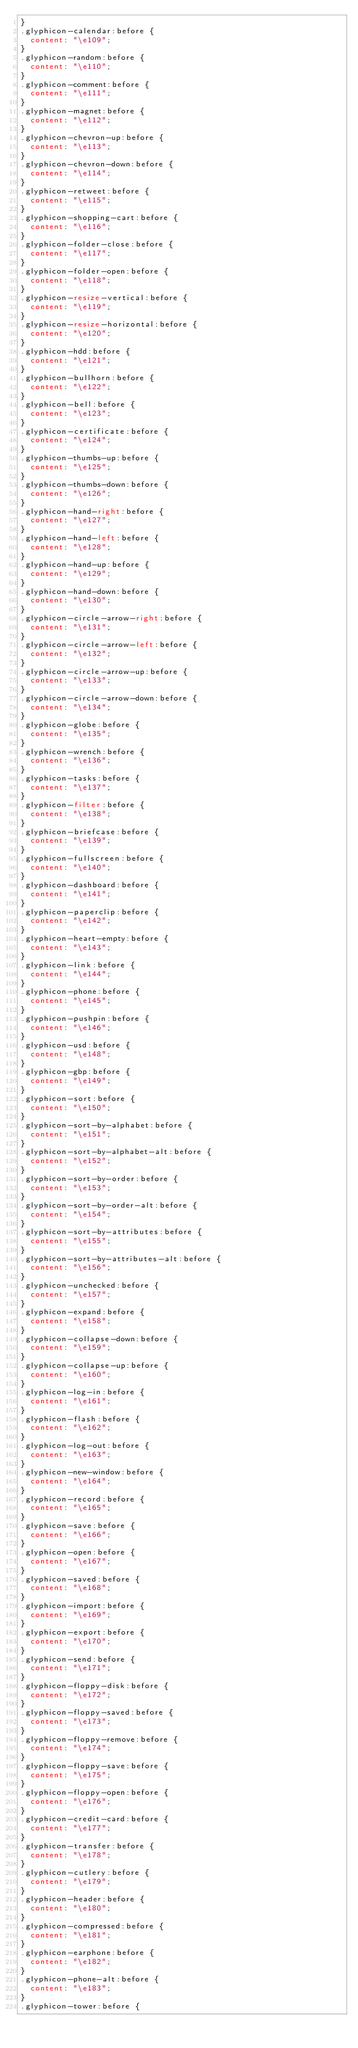<code> <loc_0><loc_0><loc_500><loc_500><_CSS_>}
.glyphicon-calendar:before {
  content: "\e109";
}
.glyphicon-random:before {
  content: "\e110";
}
.glyphicon-comment:before {
  content: "\e111";
}
.glyphicon-magnet:before {
  content: "\e112";
}
.glyphicon-chevron-up:before {
  content: "\e113";
}
.glyphicon-chevron-down:before {
  content: "\e114";
}
.glyphicon-retweet:before {
  content: "\e115";
}
.glyphicon-shopping-cart:before {
  content: "\e116";
}
.glyphicon-folder-close:before {
  content: "\e117";
}
.glyphicon-folder-open:before {
  content: "\e118";
}
.glyphicon-resize-vertical:before {
  content: "\e119";
}
.glyphicon-resize-horizontal:before {
  content: "\e120";
}
.glyphicon-hdd:before {
  content: "\e121";
}
.glyphicon-bullhorn:before {
  content: "\e122";
}
.glyphicon-bell:before {
  content: "\e123";
}
.glyphicon-certificate:before {
  content: "\e124";
}
.glyphicon-thumbs-up:before {
  content: "\e125";
}
.glyphicon-thumbs-down:before {
  content: "\e126";
}
.glyphicon-hand-right:before {
  content: "\e127";
}
.glyphicon-hand-left:before {
  content: "\e128";
}
.glyphicon-hand-up:before {
  content: "\e129";
}
.glyphicon-hand-down:before {
  content: "\e130";
}
.glyphicon-circle-arrow-right:before {
  content: "\e131";
}
.glyphicon-circle-arrow-left:before {
  content: "\e132";
}
.glyphicon-circle-arrow-up:before {
  content: "\e133";
}
.glyphicon-circle-arrow-down:before {
  content: "\e134";
}
.glyphicon-globe:before {
  content: "\e135";
}
.glyphicon-wrench:before {
  content: "\e136";
}
.glyphicon-tasks:before {
  content: "\e137";
}
.glyphicon-filter:before {
  content: "\e138";
}
.glyphicon-briefcase:before {
  content: "\e139";
}
.glyphicon-fullscreen:before {
  content: "\e140";
}
.glyphicon-dashboard:before {
  content: "\e141";
}
.glyphicon-paperclip:before {
  content: "\e142";
}
.glyphicon-heart-empty:before {
  content: "\e143";
}
.glyphicon-link:before {
  content: "\e144";
}
.glyphicon-phone:before {
  content: "\e145";
}
.glyphicon-pushpin:before {
  content: "\e146";
}
.glyphicon-usd:before {
  content: "\e148";
}
.glyphicon-gbp:before {
  content: "\e149";
}
.glyphicon-sort:before {
  content: "\e150";
}
.glyphicon-sort-by-alphabet:before {
  content: "\e151";
}
.glyphicon-sort-by-alphabet-alt:before {
  content: "\e152";
}
.glyphicon-sort-by-order:before {
  content: "\e153";
}
.glyphicon-sort-by-order-alt:before {
  content: "\e154";
}
.glyphicon-sort-by-attributes:before {
  content: "\e155";
}
.glyphicon-sort-by-attributes-alt:before {
  content: "\e156";
}
.glyphicon-unchecked:before {
  content: "\e157";
}
.glyphicon-expand:before {
  content: "\e158";
}
.glyphicon-collapse-down:before {
  content: "\e159";
}
.glyphicon-collapse-up:before {
  content: "\e160";
}
.glyphicon-log-in:before {
  content: "\e161";
}
.glyphicon-flash:before {
  content: "\e162";
}
.glyphicon-log-out:before {
  content: "\e163";
}
.glyphicon-new-window:before {
  content: "\e164";
}
.glyphicon-record:before {
  content: "\e165";
}
.glyphicon-save:before {
  content: "\e166";
}
.glyphicon-open:before {
  content: "\e167";
}
.glyphicon-saved:before {
  content: "\e168";
}
.glyphicon-import:before {
  content: "\e169";
}
.glyphicon-export:before {
  content: "\e170";
}
.glyphicon-send:before {
  content: "\e171";
}
.glyphicon-floppy-disk:before {
  content: "\e172";
}
.glyphicon-floppy-saved:before {
  content: "\e173";
}
.glyphicon-floppy-remove:before {
  content: "\e174";
}
.glyphicon-floppy-save:before {
  content: "\e175";
}
.glyphicon-floppy-open:before {
  content: "\e176";
}
.glyphicon-credit-card:before {
  content: "\e177";
}
.glyphicon-transfer:before {
  content: "\e178";
}
.glyphicon-cutlery:before {
  content: "\e179";
}
.glyphicon-header:before {
  content: "\e180";
}
.glyphicon-compressed:before {
  content: "\e181";
}
.glyphicon-earphone:before {
  content: "\e182";
}
.glyphicon-phone-alt:before {
  content: "\e183";
}
.glyphicon-tower:before {</code> 